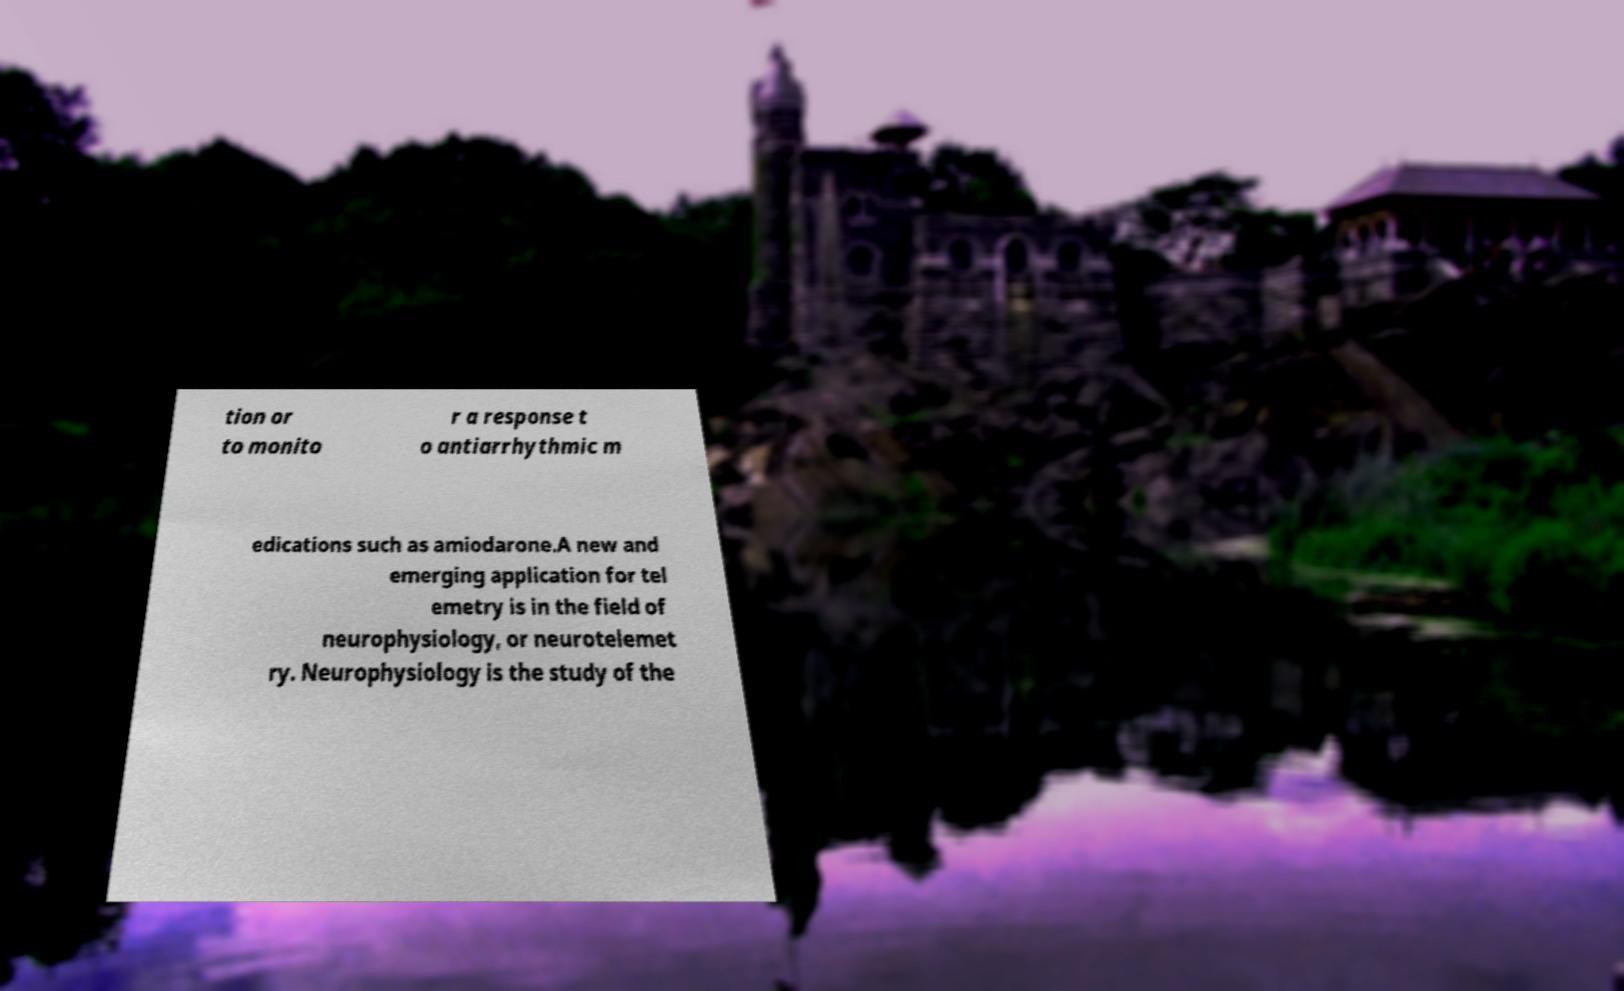Could you assist in decoding the text presented in this image and type it out clearly? tion or to monito r a response t o antiarrhythmic m edications such as amiodarone.A new and emerging application for tel emetry is in the field of neurophysiology, or neurotelemet ry. Neurophysiology is the study of the 